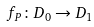<formula> <loc_0><loc_0><loc_500><loc_500>f _ { P } \colon D _ { 0 } \rightarrow D _ { 1 }</formula> 